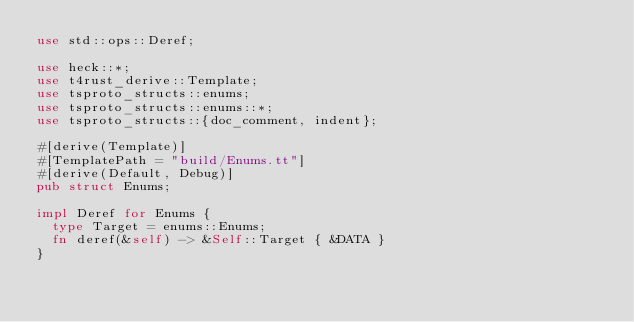Convert code to text. <code><loc_0><loc_0><loc_500><loc_500><_Rust_>use std::ops::Deref;

use heck::*;
use t4rust_derive::Template;
use tsproto_structs::enums;
use tsproto_structs::enums::*;
use tsproto_structs::{doc_comment, indent};

#[derive(Template)]
#[TemplatePath = "build/Enums.tt"]
#[derive(Default, Debug)]
pub struct Enums;

impl Deref for Enums {
	type Target = enums::Enums;
	fn deref(&self) -> &Self::Target { &DATA }
}
</code> 